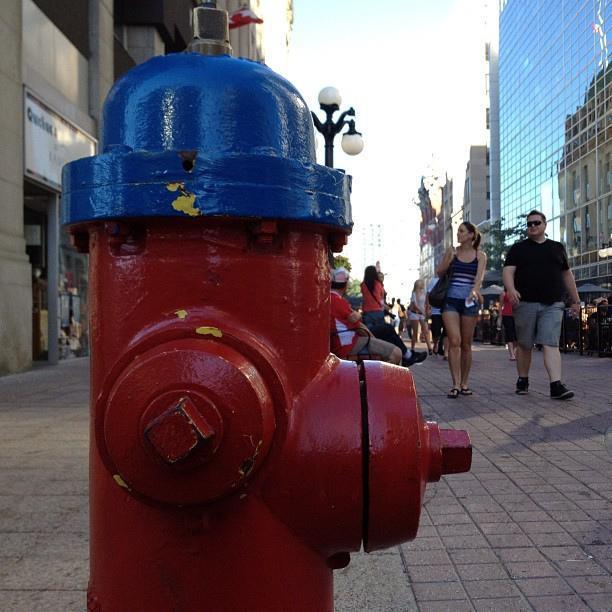How many people can you see?
Give a very brief answer. 3. How many elephants have tusks?
Give a very brief answer. 0. 